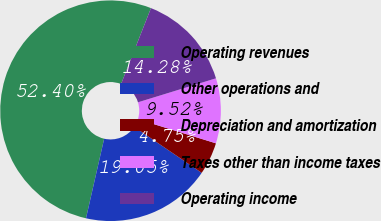<chart> <loc_0><loc_0><loc_500><loc_500><pie_chart><fcel>Operating revenues<fcel>Other operations and<fcel>Depreciation and amortization<fcel>Taxes other than income taxes<fcel>Operating income<nl><fcel>52.4%<fcel>19.05%<fcel>4.75%<fcel>9.52%<fcel>14.28%<nl></chart> 